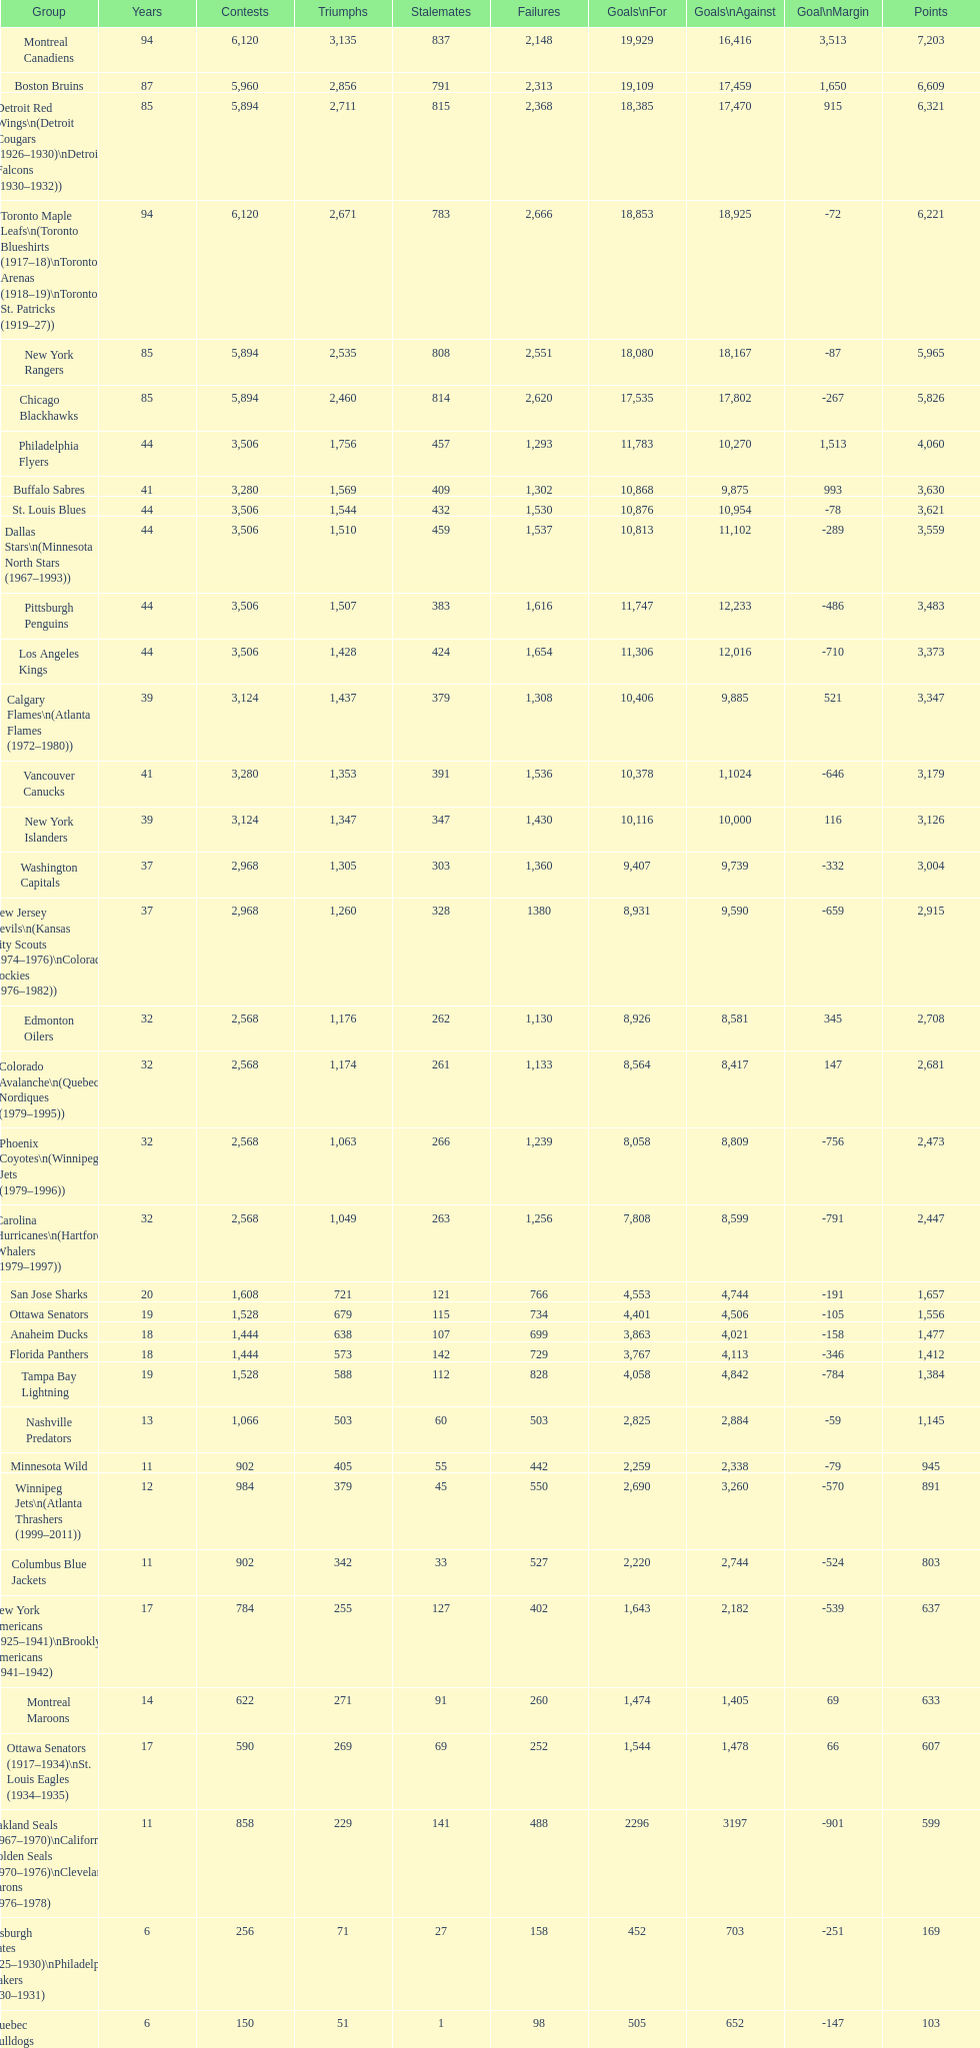Who is at the top of the list? Montreal Canadiens. 